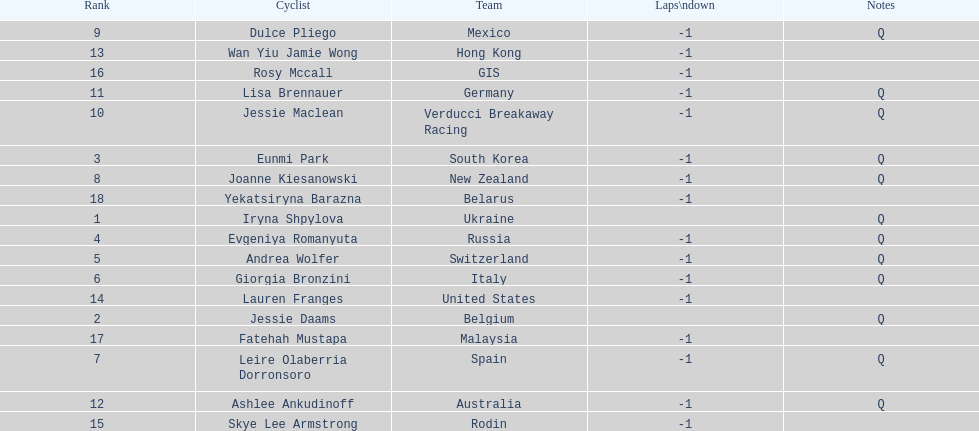What two cyclists come from teams with no laps down? Iryna Shpylova, Jessie Daams. 